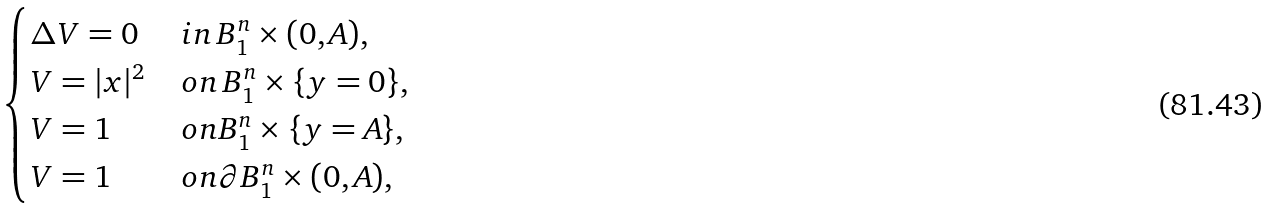Convert formula to latex. <formula><loc_0><loc_0><loc_500><loc_500>\begin{cases} \Delta V = 0 \, & i n \, B _ { 1 } ^ { n } \times ( 0 , A ) , \\ V = | x | ^ { 2 } \, & o n \, B _ { 1 } ^ { n } \times \{ y = 0 \} , \\ V = 1 \, & o n B _ { 1 } ^ { n } \times \{ y = A \} , \\ V = 1 \, & o n \partial B _ { 1 } ^ { n } \times ( 0 , A ) , \end{cases}</formula> 